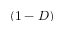Convert formula to latex. <formula><loc_0><loc_0><loc_500><loc_500>( 1 - D )</formula> 